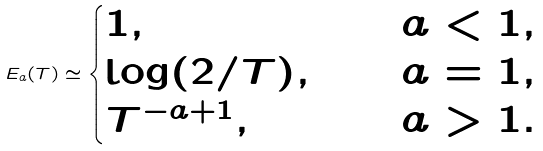<formula> <loc_0><loc_0><loc_500><loc_500>E _ { a } ( T ) \simeq \begin{cases} 1 , & \quad a < 1 , \\ \log ( 2 \slash T ) , & \quad a = 1 , \\ T ^ { - a + 1 } , & \quad a > 1 . \end{cases}</formula> 